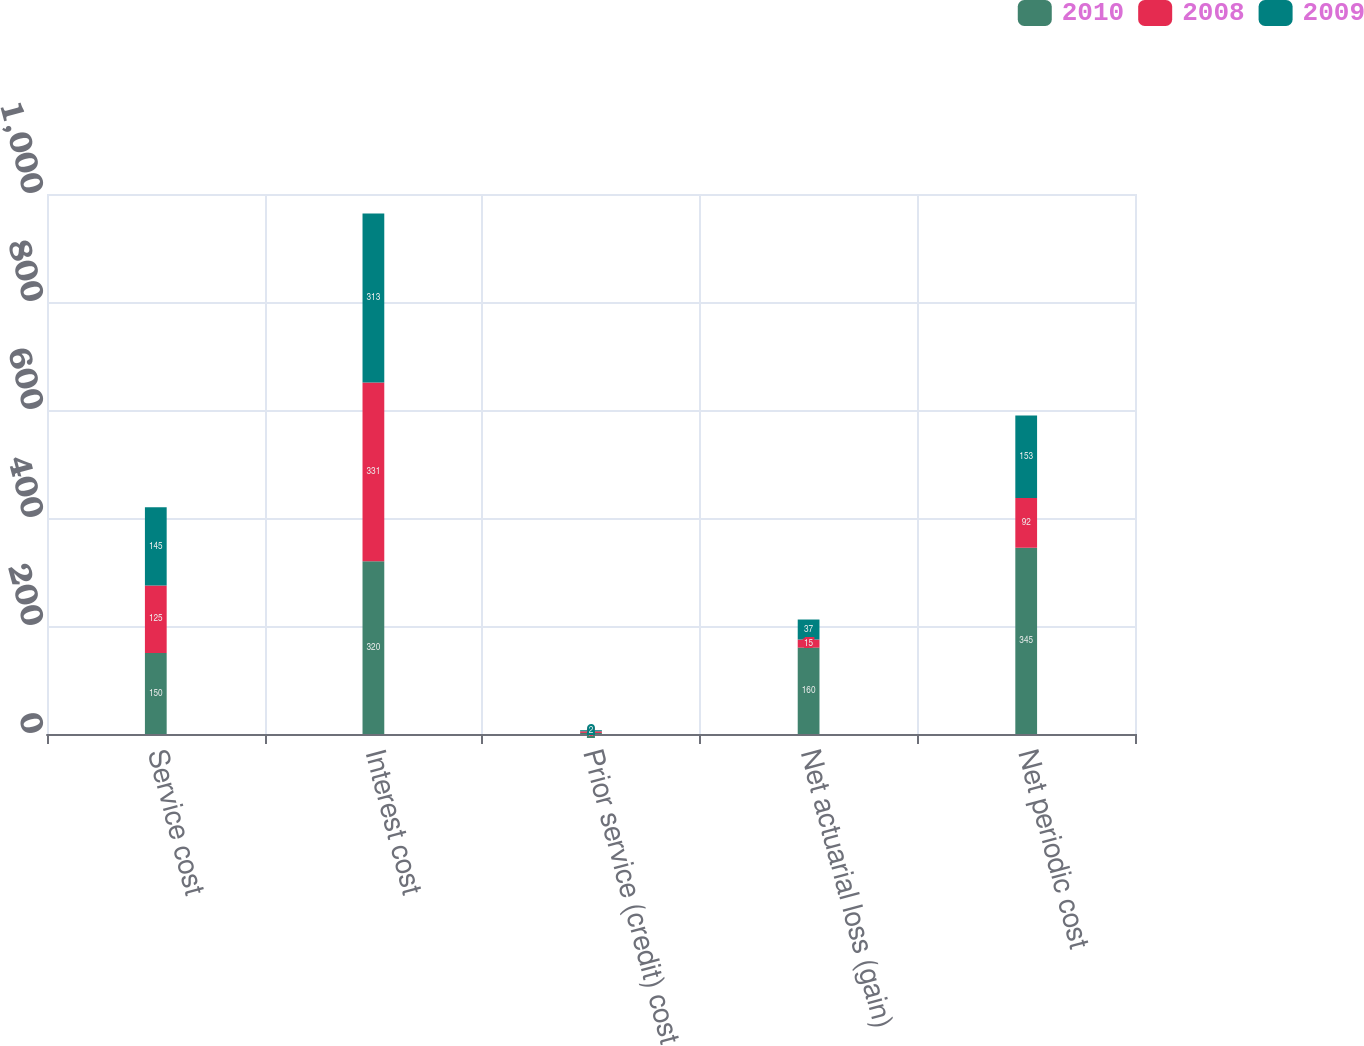Convert chart to OTSL. <chart><loc_0><loc_0><loc_500><loc_500><stacked_bar_chart><ecel><fcel>Service cost<fcel>Interest cost<fcel>Prior service (credit) cost<fcel>Net actuarial loss (gain)<fcel>Net periodic cost<nl><fcel>2010<fcel>150<fcel>320<fcel>2<fcel>160<fcel>345<nl><fcel>2008<fcel>125<fcel>331<fcel>3<fcel>15<fcel>92<nl><fcel>2009<fcel>145<fcel>313<fcel>2<fcel>37<fcel>153<nl></chart> 